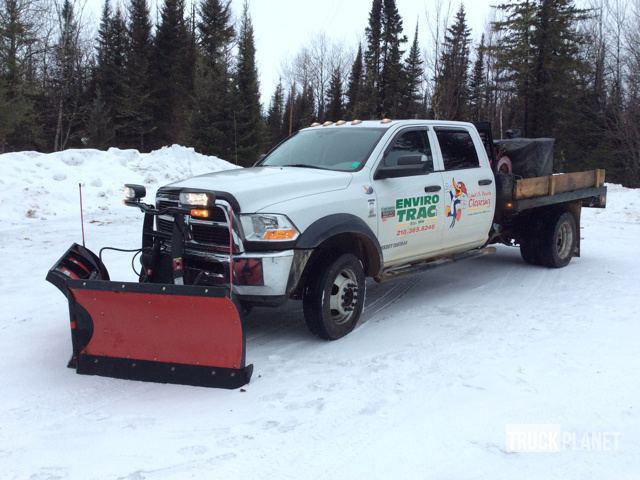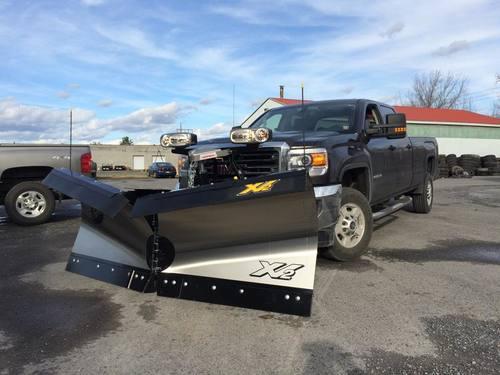The first image is the image on the left, the second image is the image on the right. For the images shown, is this caption "The left and right image contains the same number of black trucks with a plow." true? Answer yes or no. No. 